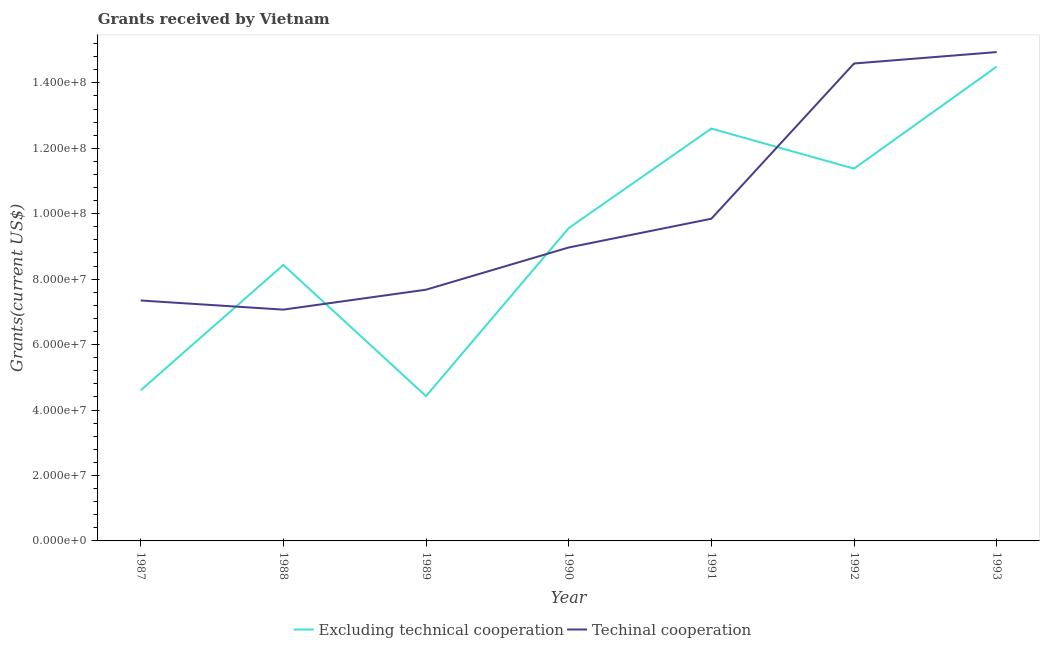Is the number of lines equal to the number of legend labels?
Make the answer very short. Yes. What is the amount of grants received(excluding technical cooperation) in 1992?
Provide a succinct answer. 1.14e+08. Across all years, what is the maximum amount of grants received(including technical cooperation)?
Offer a very short reply. 1.49e+08. Across all years, what is the minimum amount of grants received(including technical cooperation)?
Offer a terse response. 7.07e+07. What is the total amount of grants received(excluding technical cooperation) in the graph?
Ensure brevity in your answer.  6.55e+08. What is the difference between the amount of grants received(excluding technical cooperation) in 1988 and that in 1990?
Provide a succinct answer. -1.12e+07. What is the difference between the amount of grants received(including technical cooperation) in 1991 and the amount of grants received(excluding technical cooperation) in 1990?
Provide a succinct answer. 2.87e+06. What is the average amount of grants received(including technical cooperation) per year?
Make the answer very short. 1.01e+08. In the year 1991, what is the difference between the amount of grants received(including technical cooperation) and amount of grants received(excluding technical cooperation)?
Offer a very short reply. -2.76e+07. In how many years, is the amount of grants received(excluding technical cooperation) greater than 76000000 US$?
Keep it short and to the point. 5. What is the ratio of the amount of grants received(including technical cooperation) in 1988 to that in 1989?
Provide a succinct answer. 0.92. Is the amount of grants received(including technical cooperation) in 1987 less than that in 1989?
Provide a succinct answer. Yes. What is the difference between the highest and the second highest amount of grants received(including technical cooperation)?
Give a very brief answer. 3.49e+06. What is the difference between the highest and the lowest amount of grants received(including technical cooperation)?
Ensure brevity in your answer.  7.87e+07. In how many years, is the amount of grants received(excluding technical cooperation) greater than the average amount of grants received(excluding technical cooperation) taken over all years?
Offer a terse response. 4. Is the amount of grants received(including technical cooperation) strictly greater than the amount of grants received(excluding technical cooperation) over the years?
Offer a very short reply. No. Is the amount of grants received(including technical cooperation) strictly less than the amount of grants received(excluding technical cooperation) over the years?
Provide a short and direct response. No. How many years are there in the graph?
Ensure brevity in your answer.  7. Are the values on the major ticks of Y-axis written in scientific E-notation?
Ensure brevity in your answer.  Yes. Does the graph contain any zero values?
Your answer should be very brief. No. Does the graph contain grids?
Your answer should be compact. No. Where does the legend appear in the graph?
Give a very brief answer. Bottom center. How are the legend labels stacked?
Ensure brevity in your answer.  Horizontal. What is the title of the graph?
Your answer should be compact. Grants received by Vietnam. Does "Unregistered firms" appear as one of the legend labels in the graph?
Provide a short and direct response. No. What is the label or title of the Y-axis?
Provide a succinct answer. Grants(current US$). What is the Grants(current US$) of Excluding technical cooperation in 1987?
Keep it short and to the point. 4.60e+07. What is the Grants(current US$) in Techinal cooperation in 1987?
Give a very brief answer. 7.35e+07. What is the Grants(current US$) in Excluding technical cooperation in 1988?
Make the answer very short. 8.44e+07. What is the Grants(current US$) in Techinal cooperation in 1988?
Provide a short and direct response. 7.07e+07. What is the Grants(current US$) in Excluding technical cooperation in 1989?
Your answer should be very brief. 4.42e+07. What is the Grants(current US$) in Techinal cooperation in 1989?
Your response must be concise. 7.68e+07. What is the Grants(current US$) in Excluding technical cooperation in 1990?
Your response must be concise. 9.56e+07. What is the Grants(current US$) of Techinal cooperation in 1990?
Your response must be concise. 8.97e+07. What is the Grants(current US$) of Excluding technical cooperation in 1991?
Your answer should be compact. 1.26e+08. What is the Grants(current US$) in Techinal cooperation in 1991?
Offer a terse response. 9.85e+07. What is the Grants(current US$) in Excluding technical cooperation in 1992?
Your answer should be very brief. 1.14e+08. What is the Grants(current US$) of Techinal cooperation in 1992?
Give a very brief answer. 1.46e+08. What is the Grants(current US$) in Excluding technical cooperation in 1993?
Offer a very short reply. 1.45e+08. What is the Grants(current US$) of Techinal cooperation in 1993?
Your response must be concise. 1.49e+08. Across all years, what is the maximum Grants(current US$) in Excluding technical cooperation?
Provide a succinct answer. 1.45e+08. Across all years, what is the maximum Grants(current US$) in Techinal cooperation?
Give a very brief answer. 1.49e+08. Across all years, what is the minimum Grants(current US$) of Excluding technical cooperation?
Offer a terse response. 4.42e+07. Across all years, what is the minimum Grants(current US$) in Techinal cooperation?
Offer a terse response. 7.07e+07. What is the total Grants(current US$) of Excluding technical cooperation in the graph?
Give a very brief answer. 6.55e+08. What is the total Grants(current US$) in Techinal cooperation in the graph?
Your answer should be compact. 7.04e+08. What is the difference between the Grants(current US$) in Excluding technical cooperation in 1987 and that in 1988?
Keep it short and to the point. -3.83e+07. What is the difference between the Grants(current US$) in Techinal cooperation in 1987 and that in 1988?
Provide a succinct answer. 2.79e+06. What is the difference between the Grants(current US$) of Excluding technical cooperation in 1987 and that in 1989?
Offer a very short reply. 1.77e+06. What is the difference between the Grants(current US$) in Techinal cooperation in 1987 and that in 1989?
Give a very brief answer. -3.30e+06. What is the difference between the Grants(current US$) in Excluding technical cooperation in 1987 and that in 1990?
Your answer should be compact. -4.96e+07. What is the difference between the Grants(current US$) of Techinal cooperation in 1987 and that in 1990?
Give a very brief answer. -1.62e+07. What is the difference between the Grants(current US$) in Excluding technical cooperation in 1987 and that in 1991?
Keep it short and to the point. -8.00e+07. What is the difference between the Grants(current US$) of Techinal cooperation in 1987 and that in 1991?
Your response must be concise. -2.50e+07. What is the difference between the Grants(current US$) of Excluding technical cooperation in 1987 and that in 1992?
Your answer should be very brief. -6.78e+07. What is the difference between the Grants(current US$) in Techinal cooperation in 1987 and that in 1992?
Provide a succinct answer. -7.24e+07. What is the difference between the Grants(current US$) in Excluding technical cooperation in 1987 and that in 1993?
Provide a short and direct response. -9.89e+07. What is the difference between the Grants(current US$) in Techinal cooperation in 1987 and that in 1993?
Offer a very short reply. -7.59e+07. What is the difference between the Grants(current US$) in Excluding technical cooperation in 1988 and that in 1989?
Make the answer very short. 4.01e+07. What is the difference between the Grants(current US$) of Techinal cooperation in 1988 and that in 1989?
Your response must be concise. -6.09e+06. What is the difference between the Grants(current US$) in Excluding technical cooperation in 1988 and that in 1990?
Offer a terse response. -1.12e+07. What is the difference between the Grants(current US$) of Techinal cooperation in 1988 and that in 1990?
Give a very brief answer. -1.90e+07. What is the difference between the Grants(current US$) in Excluding technical cooperation in 1988 and that in 1991?
Offer a very short reply. -4.17e+07. What is the difference between the Grants(current US$) of Techinal cooperation in 1988 and that in 1991?
Your answer should be very brief. -2.78e+07. What is the difference between the Grants(current US$) in Excluding technical cooperation in 1988 and that in 1992?
Keep it short and to the point. -2.94e+07. What is the difference between the Grants(current US$) of Techinal cooperation in 1988 and that in 1992?
Your answer should be very brief. -7.52e+07. What is the difference between the Grants(current US$) of Excluding technical cooperation in 1988 and that in 1993?
Your response must be concise. -6.06e+07. What is the difference between the Grants(current US$) of Techinal cooperation in 1988 and that in 1993?
Ensure brevity in your answer.  -7.87e+07. What is the difference between the Grants(current US$) of Excluding technical cooperation in 1989 and that in 1990?
Your response must be concise. -5.14e+07. What is the difference between the Grants(current US$) of Techinal cooperation in 1989 and that in 1990?
Keep it short and to the point. -1.29e+07. What is the difference between the Grants(current US$) in Excluding technical cooperation in 1989 and that in 1991?
Your answer should be compact. -8.18e+07. What is the difference between the Grants(current US$) in Techinal cooperation in 1989 and that in 1991?
Offer a terse response. -2.17e+07. What is the difference between the Grants(current US$) of Excluding technical cooperation in 1989 and that in 1992?
Keep it short and to the point. -6.95e+07. What is the difference between the Grants(current US$) of Techinal cooperation in 1989 and that in 1992?
Provide a short and direct response. -6.91e+07. What is the difference between the Grants(current US$) of Excluding technical cooperation in 1989 and that in 1993?
Offer a very short reply. -1.01e+08. What is the difference between the Grants(current US$) in Techinal cooperation in 1989 and that in 1993?
Keep it short and to the point. -7.26e+07. What is the difference between the Grants(current US$) in Excluding technical cooperation in 1990 and that in 1991?
Provide a short and direct response. -3.04e+07. What is the difference between the Grants(current US$) in Techinal cooperation in 1990 and that in 1991?
Make the answer very short. -8.79e+06. What is the difference between the Grants(current US$) in Excluding technical cooperation in 1990 and that in 1992?
Your answer should be compact. -1.82e+07. What is the difference between the Grants(current US$) in Techinal cooperation in 1990 and that in 1992?
Your response must be concise. -5.62e+07. What is the difference between the Grants(current US$) in Excluding technical cooperation in 1990 and that in 1993?
Provide a succinct answer. -4.94e+07. What is the difference between the Grants(current US$) of Techinal cooperation in 1990 and that in 1993?
Ensure brevity in your answer.  -5.97e+07. What is the difference between the Grants(current US$) of Excluding technical cooperation in 1991 and that in 1992?
Give a very brief answer. 1.22e+07. What is the difference between the Grants(current US$) of Techinal cooperation in 1991 and that in 1992?
Your response must be concise. -4.74e+07. What is the difference between the Grants(current US$) in Excluding technical cooperation in 1991 and that in 1993?
Give a very brief answer. -1.89e+07. What is the difference between the Grants(current US$) in Techinal cooperation in 1991 and that in 1993?
Offer a terse response. -5.09e+07. What is the difference between the Grants(current US$) in Excluding technical cooperation in 1992 and that in 1993?
Keep it short and to the point. -3.12e+07. What is the difference between the Grants(current US$) in Techinal cooperation in 1992 and that in 1993?
Provide a succinct answer. -3.49e+06. What is the difference between the Grants(current US$) in Excluding technical cooperation in 1987 and the Grants(current US$) in Techinal cooperation in 1988?
Offer a very short reply. -2.47e+07. What is the difference between the Grants(current US$) in Excluding technical cooperation in 1987 and the Grants(current US$) in Techinal cooperation in 1989?
Keep it short and to the point. -3.08e+07. What is the difference between the Grants(current US$) of Excluding technical cooperation in 1987 and the Grants(current US$) of Techinal cooperation in 1990?
Your answer should be compact. -4.37e+07. What is the difference between the Grants(current US$) of Excluding technical cooperation in 1987 and the Grants(current US$) of Techinal cooperation in 1991?
Ensure brevity in your answer.  -5.24e+07. What is the difference between the Grants(current US$) of Excluding technical cooperation in 1987 and the Grants(current US$) of Techinal cooperation in 1992?
Provide a short and direct response. -9.99e+07. What is the difference between the Grants(current US$) in Excluding technical cooperation in 1987 and the Grants(current US$) in Techinal cooperation in 1993?
Give a very brief answer. -1.03e+08. What is the difference between the Grants(current US$) in Excluding technical cooperation in 1988 and the Grants(current US$) in Techinal cooperation in 1989?
Ensure brevity in your answer.  7.57e+06. What is the difference between the Grants(current US$) of Excluding technical cooperation in 1988 and the Grants(current US$) of Techinal cooperation in 1990?
Your answer should be compact. -5.33e+06. What is the difference between the Grants(current US$) in Excluding technical cooperation in 1988 and the Grants(current US$) in Techinal cooperation in 1991?
Give a very brief answer. -1.41e+07. What is the difference between the Grants(current US$) of Excluding technical cooperation in 1988 and the Grants(current US$) of Techinal cooperation in 1992?
Keep it short and to the point. -6.16e+07. What is the difference between the Grants(current US$) in Excluding technical cooperation in 1988 and the Grants(current US$) in Techinal cooperation in 1993?
Ensure brevity in your answer.  -6.50e+07. What is the difference between the Grants(current US$) of Excluding technical cooperation in 1989 and the Grants(current US$) of Techinal cooperation in 1990?
Give a very brief answer. -4.54e+07. What is the difference between the Grants(current US$) of Excluding technical cooperation in 1989 and the Grants(current US$) of Techinal cooperation in 1991?
Make the answer very short. -5.42e+07. What is the difference between the Grants(current US$) of Excluding technical cooperation in 1989 and the Grants(current US$) of Techinal cooperation in 1992?
Your response must be concise. -1.02e+08. What is the difference between the Grants(current US$) of Excluding technical cooperation in 1989 and the Grants(current US$) of Techinal cooperation in 1993?
Your answer should be compact. -1.05e+08. What is the difference between the Grants(current US$) in Excluding technical cooperation in 1990 and the Grants(current US$) in Techinal cooperation in 1991?
Your answer should be compact. -2.87e+06. What is the difference between the Grants(current US$) in Excluding technical cooperation in 1990 and the Grants(current US$) in Techinal cooperation in 1992?
Provide a short and direct response. -5.03e+07. What is the difference between the Grants(current US$) of Excluding technical cooperation in 1990 and the Grants(current US$) of Techinal cooperation in 1993?
Make the answer very short. -5.38e+07. What is the difference between the Grants(current US$) of Excluding technical cooperation in 1991 and the Grants(current US$) of Techinal cooperation in 1992?
Give a very brief answer. -1.99e+07. What is the difference between the Grants(current US$) of Excluding technical cooperation in 1991 and the Grants(current US$) of Techinal cooperation in 1993?
Your response must be concise. -2.34e+07. What is the difference between the Grants(current US$) in Excluding technical cooperation in 1992 and the Grants(current US$) in Techinal cooperation in 1993?
Make the answer very short. -3.56e+07. What is the average Grants(current US$) in Excluding technical cooperation per year?
Provide a short and direct response. 9.36e+07. What is the average Grants(current US$) in Techinal cooperation per year?
Your answer should be very brief. 1.01e+08. In the year 1987, what is the difference between the Grants(current US$) of Excluding technical cooperation and Grants(current US$) of Techinal cooperation?
Ensure brevity in your answer.  -2.75e+07. In the year 1988, what is the difference between the Grants(current US$) of Excluding technical cooperation and Grants(current US$) of Techinal cooperation?
Offer a terse response. 1.37e+07. In the year 1989, what is the difference between the Grants(current US$) in Excluding technical cooperation and Grants(current US$) in Techinal cooperation?
Offer a very short reply. -3.25e+07. In the year 1990, what is the difference between the Grants(current US$) in Excluding technical cooperation and Grants(current US$) in Techinal cooperation?
Offer a terse response. 5.92e+06. In the year 1991, what is the difference between the Grants(current US$) in Excluding technical cooperation and Grants(current US$) in Techinal cooperation?
Provide a succinct answer. 2.76e+07. In the year 1992, what is the difference between the Grants(current US$) of Excluding technical cooperation and Grants(current US$) of Techinal cooperation?
Ensure brevity in your answer.  -3.21e+07. In the year 1993, what is the difference between the Grants(current US$) of Excluding technical cooperation and Grants(current US$) of Techinal cooperation?
Give a very brief answer. -4.44e+06. What is the ratio of the Grants(current US$) in Excluding technical cooperation in 1987 to that in 1988?
Your response must be concise. 0.55. What is the ratio of the Grants(current US$) of Techinal cooperation in 1987 to that in 1988?
Offer a very short reply. 1.04. What is the ratio of the Grants(current US$) of Excluding technical cooperation in 1987 to that in 1990?
Provide a short and direct response. 0.48. What is the ratio of the Grants(current US$) of Techinal cooperation in 1987 to that in 1990?
Provide a short and direct response. 0.82. What is the ratio of the Grants(current US$) of Excluding technical cooperation in 1987 to that in 1991?
Offer a very short reply. 0.37. What is the ratio of the Grants(current US$) in Techinal cooperation in 1987 to that in 1991?
Provide a succinct answer. 0.75. What is the ratio of the Grants(current US$) in Excluding technical cooperation in 1987 to that in 1992?
Provide a short and direct response. 0.4. What is the ratio of the Grants(current US$) in Techinal cooperation in 1987 to that in 1992?
Ensure brevity in your answer.  0.5. What is the ratio of the Grants(current US$) in Excluding technical cooperation in 1987 to that in 1993?
Offer a very short reply. 0.32. What is the ratio of the Grants(current US$) of Techinal cooperation in 1987 to that in 1993?
Make the answer very short. 0.49. What is the ratio of the Grants(current US$) of Excluding technical cooperation in 1988 to that in 1989?
Provide a succinct answer. 1.91. What is the ratio of the Grants(current US$) in Techinal cooperation in 1988 to that in 1989?
Give a very brief answer. 0.92. What is the ratio of the Grants(current US$) in Excluding technical cooperation in 1988 to that in 1990?
Your response must be concise. 0.88. What is the ratio of the Grants(current US$) of Techinal cooperation in 1988 to that in 1990?
Provide a short and direct response. 0.79. What is the ratio of the Grants(current US$) in Excluding technical cooperation in 1988 to that in 1991?
Provide a short and direct response. 0.67. What is the ratio of the Grants(current US$) in Techinal cooperation in 1988 to that in 1991?
Offer a terse response. 0.72. What is the ratio of the Grants(current US$) of Excluding technical cooperation in 1988 to that in 1992?
Give a very brief answer. 0.74. What is the ratio of the Grants(current US$) of Techinal cooperation in 1988 to that in 1992?
Your response must be concise. 0.48. What is the ratio of the Grants(current US$) in Excluding technical cooperation in 1988 to that in 1993?
Offer a very short reply. 0.58. What is the ratio of the Grants(current US$) of Techinal cooperation in 1988 to that in 1993?
Your response must be concise. 0.47. What is the ratio of the Grants(current US$) of Excluding technical cooperation in 1989 to that in 1990?
Offer a very short reply. 0.46. What is the ratio of the Grants(current US$) in Techinal cooperation in 1989 to that in 1990?
Ensure brevity in your answer.  0.86. What is the ratio of the Grants(current US$) of Excluding technical cooperation in 1989 to that in 1991?
Your answer should be compact. 0.35. What is the ratio of the Grants(current US$) in Techinal cooperation in 1989 to that in 1991?
Ensure brevity in your answer.  0.78. What is the ratio of the Grants(current US$) in Excluding technical cooperation in 1989 to that in 1992?
Your answer should be compact. 0.39. What is the ratio of the Grants(current US$) in Techinal cooperation in 1989 to that in 1992?
Your answer should be compact. 0.53. What is the ratio of the Grants(current US$) of Excluding technical cooperation in 1989 to that in 1993?
Your response must be concise. 0.31. What is the ratio of the Grants(current US$) of Techinal cooperation in 1989 to that in 1993?
Ensure brevity in your answer.  0.51. What is the ratio of the Grants(current US$) of Excluding technical cooperation in 1990 to that in 1991?
Provide a succinct answer. 0.76. What is the ratio of the Grants(current US$) in Techinal cooperation in 1990 to that in 1991?
Make the answer very short. 0.91. What is the ratio of the Grants(current US$) in Excluding technical cooperation in 1990 to that in 1992?
Your answer should be compact. 0.84. What is the ratio of the Grants(current US$) of Techinal cooperation in 1990 to that in 1992?
Make the answer very short. 0.61. What is the ratio of the Grants(current US$) in Excluding technical cooperation in 1990 to that in 1993?
Keep it short and to the point. 0.66. What is the ratio of the Grants(current US$) of Techinal cooperation in 1990 to that in 1993?
Provide a short and direct response. 0.6. What is the ratio of the Grants(current US$) of Excluding technical cooperation in 1991 to that in 1992?
Make the answer very short. 1.11. What is the ratio of the Grants(current US$) in Techinal cooperation in 1991 to that in 1992?
Keep it short and to the point. 0.67. What is the ratio of the Grants(current US$) of Excluding technical cooperation in 1991 to that in 1993?
Your response must be concise. 0.87. What is the ratio of the Grants(current US$) of Techinal cooperation in 1991 to that in 1993?
Your answer should be very brief. 0.66. What is the ratio of the Grants(current US$) in Excluding technical cooperation in 1992 to that in 1993?
Keep it short and to the point. 0.78. What is the ratio of the Grants(current US$) in Techinal cooperation in 1992 to that in 1993?
Make the answer very short. 0.98. What is the difference between the highest and the second highest Grants(current US$) of Excluding technical cooperation?
Provide a short and direct response. 1.89e+07. What is the difference between the highest and the second highest Grants(current US$) of Techinal cooperation?
Provide a succinct answer. 3.49e+06. What is the difference between the highest and the lowest Grants(current US$) in Excluding technical cooperation?
Give a very brief answer. 1.01e+08. What is the difference between the highest and the lowest Grants(current US$) in Techinal cooperation?
Make the answer very short. 7.87e+07. 